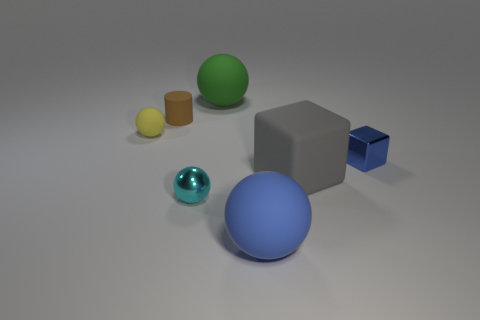What number of things are tiny metal objects on the right side of the tiny shiny sphere or rubber objects in front of the small cylinder?
Ensure brevity in your answer.  4. The block that is left of the tiny thing to the right of the green matte sphere is what color?
Provide a succinct answer. Gray. What color is the small sphere that is made of the same material as the brown object?
Ensure brevity in your answer.  Yellow. How many small shiny balls are the same color as the metallic block?
Offer a very short reply. 0. How many objects are either tiny cyan shiny things or large green spheres?
Your answer should be very brief. 2. There is a blue metallic object that is the same size as the cylinder; what shape is it?
Provide a short and direct response. Cube. What number of balls are in front of the small brown matte object and behind the tiny blue metallic thing?
Offer a very short reply. 1. There is a blue ball to the right of the tiny brown matte cylinder; what is its material?
Provide a succinct answer. Rubber. What is the size of the brown object that is made of the same material as the green thing?
Provide a short and direct response. Small. There is a blue object that is on the left side of the gray cube; does it have the same size as the metallic object that is on the right side of the big green rubber object?
Give a very brief answer. No. 